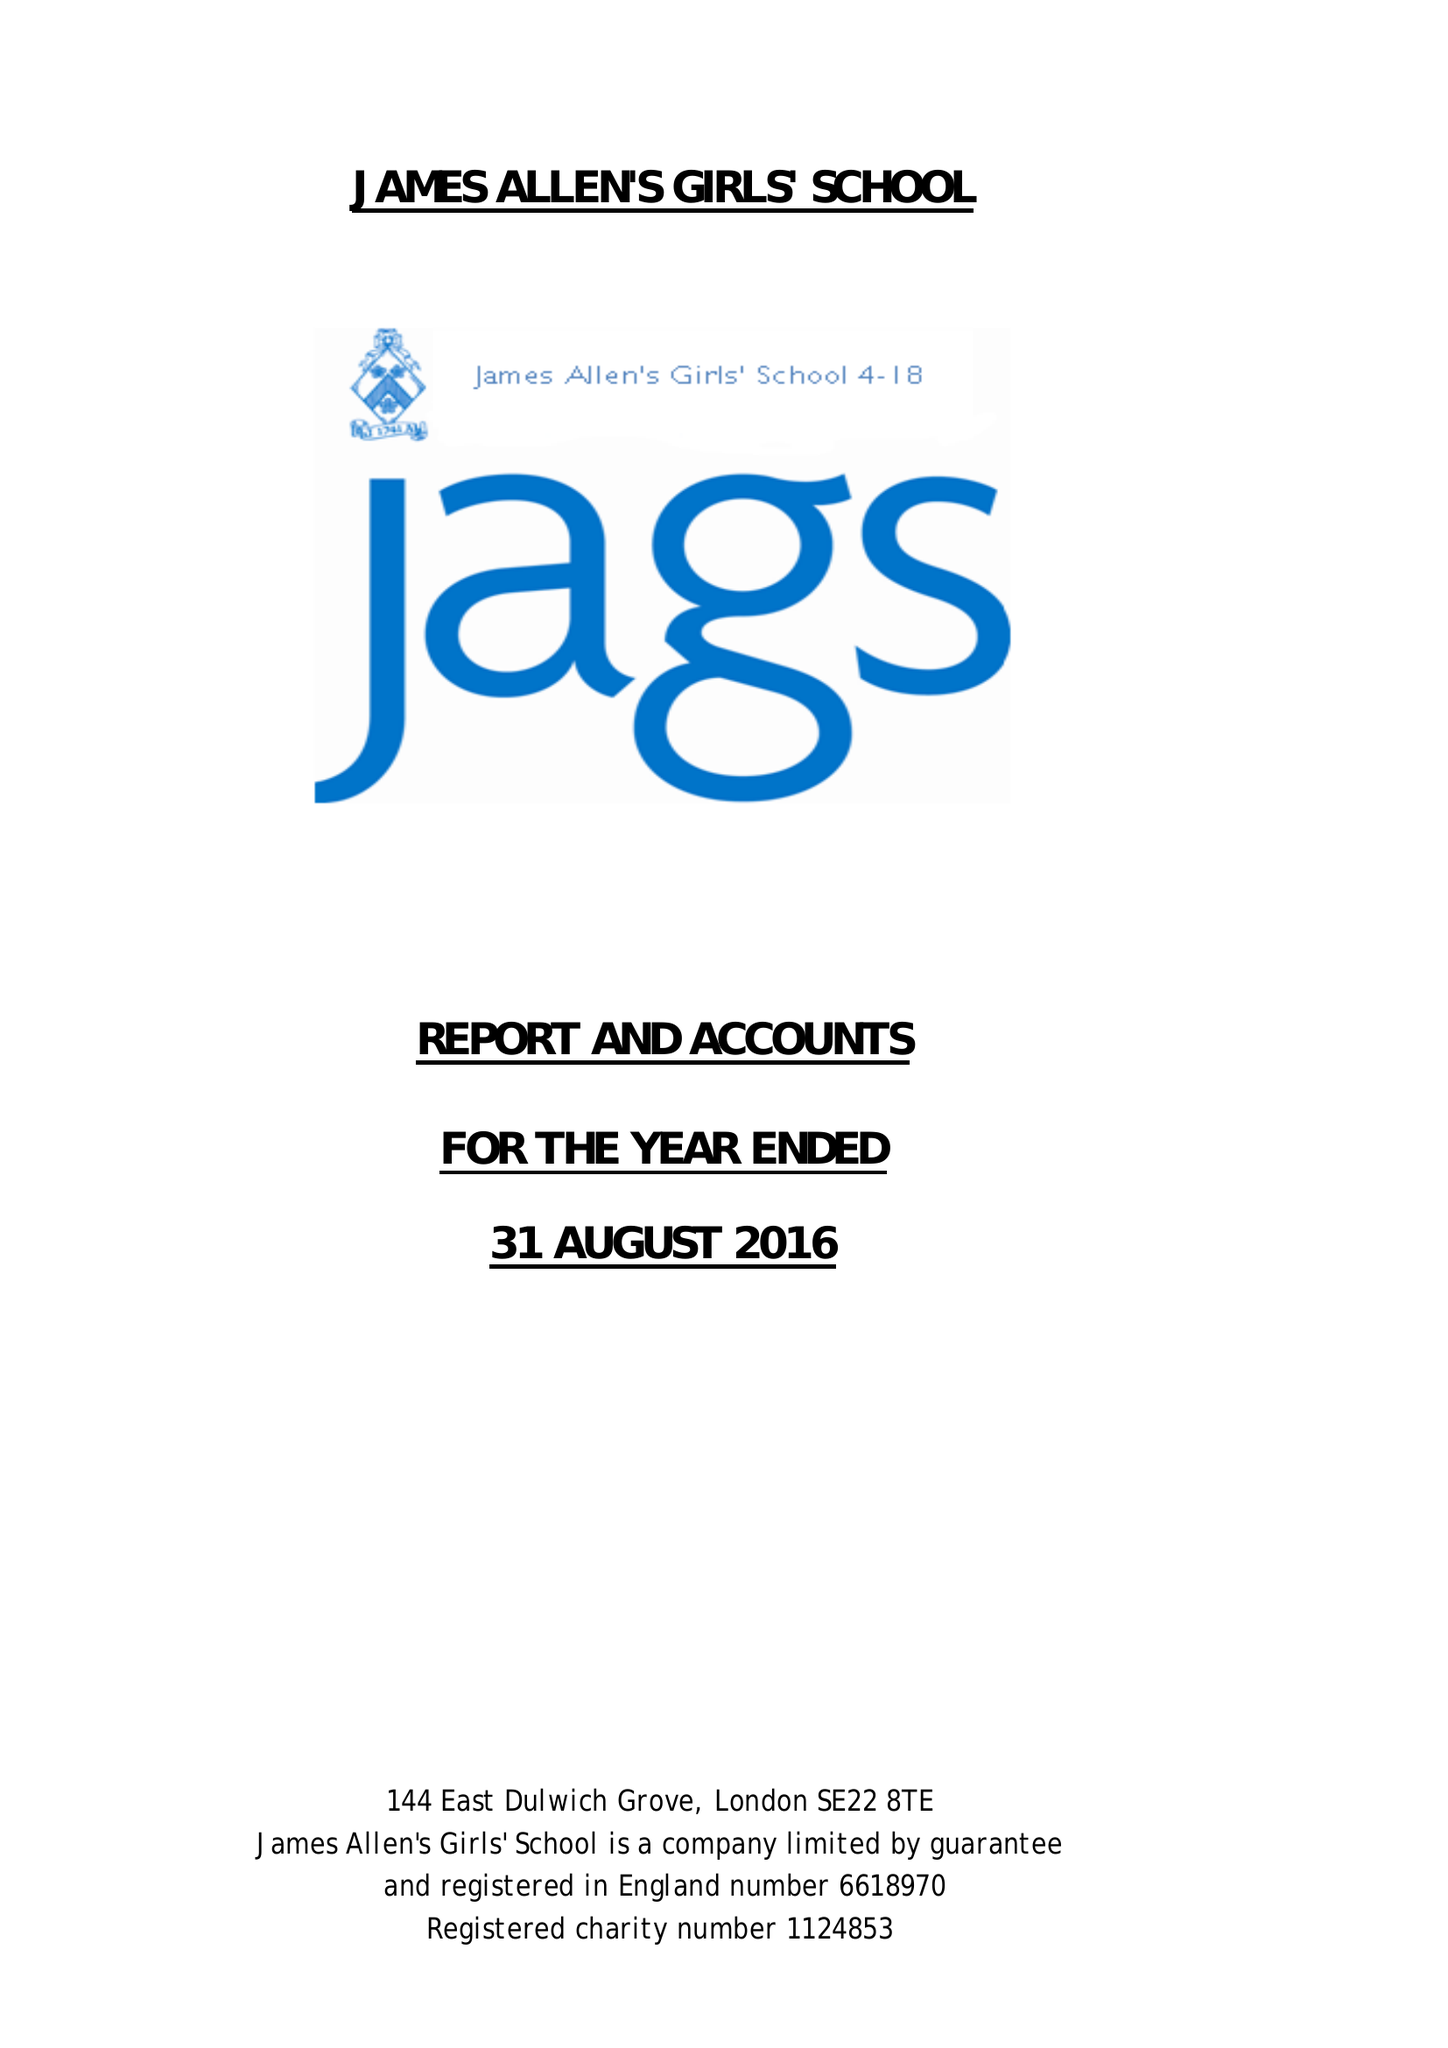What is the value for the charity_number?
Answer the question using a single word or phrase. 1124853 